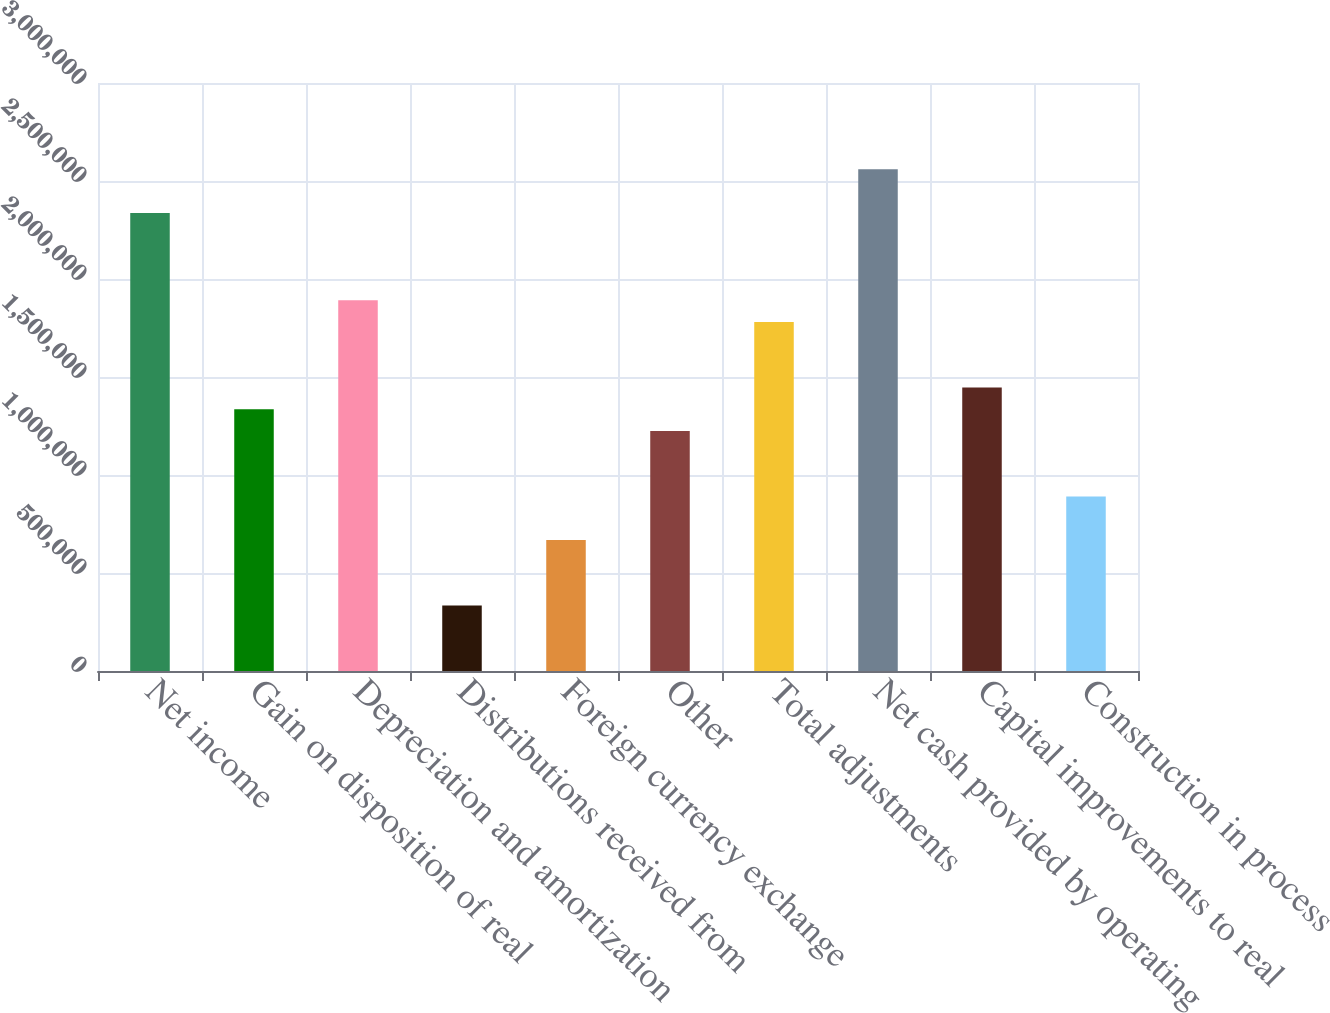Convert chart to OTSL. <chart><loc_0><loc_0><loc_500><loc_500><bar_chart><fcel>Net income<fcel>Gain on disposition of real<fcel>Depreciation and amortization<fcel>Distributions received from<fcel>Foreign currency exchange<fcel>Other<fcel>Total adjustments<fcel>Net cash provided by operating<fcel>Capital improvements to real<fcel>Construction in process<nl><fcel>2.33695e+06<fcel>1.33542e+06<fcel>1.89183e+06<fcel>333886<fcel>667731<fcel>1.22414e+06<fcel>1.78055e+06<fcel>2.55952e+06<fcel>1.4467e+06<fcel>890294<nl></chart> 